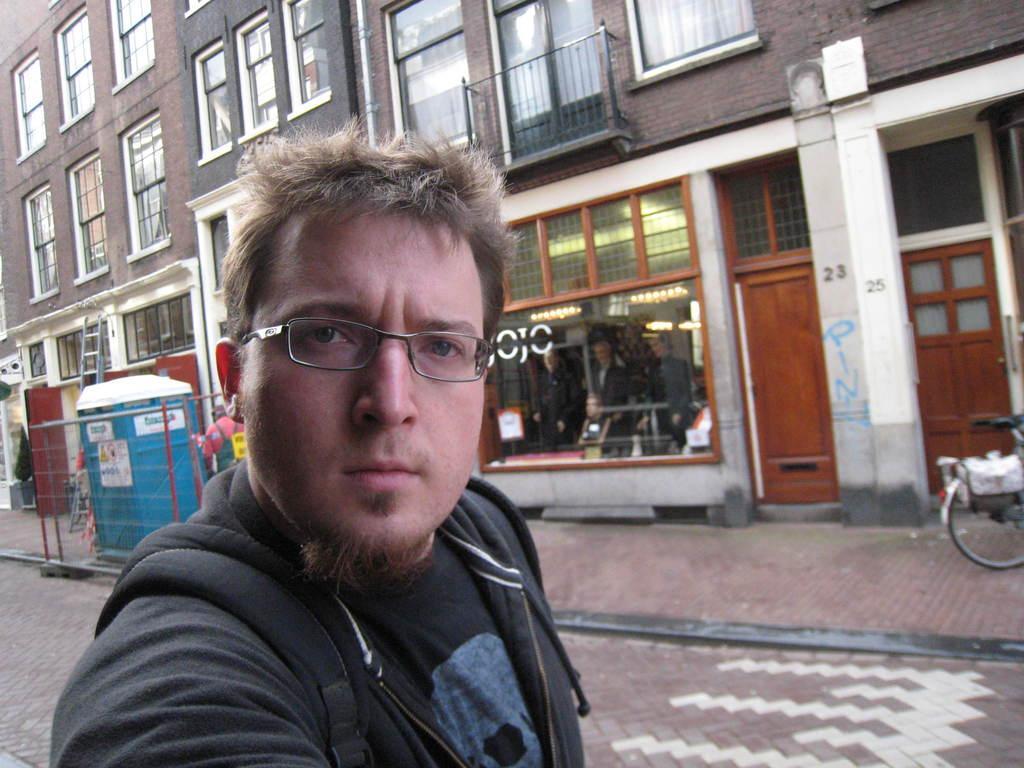In one or two sentences, can you explain what this image depicts? In this image, we can see a person is watching and wearing glasses. Background we can see buildings, walls, glass windows, railings, curtains, store, doors, box, mesh, few people, ladder and some text. On the right side of the image, we can see bicycle. 